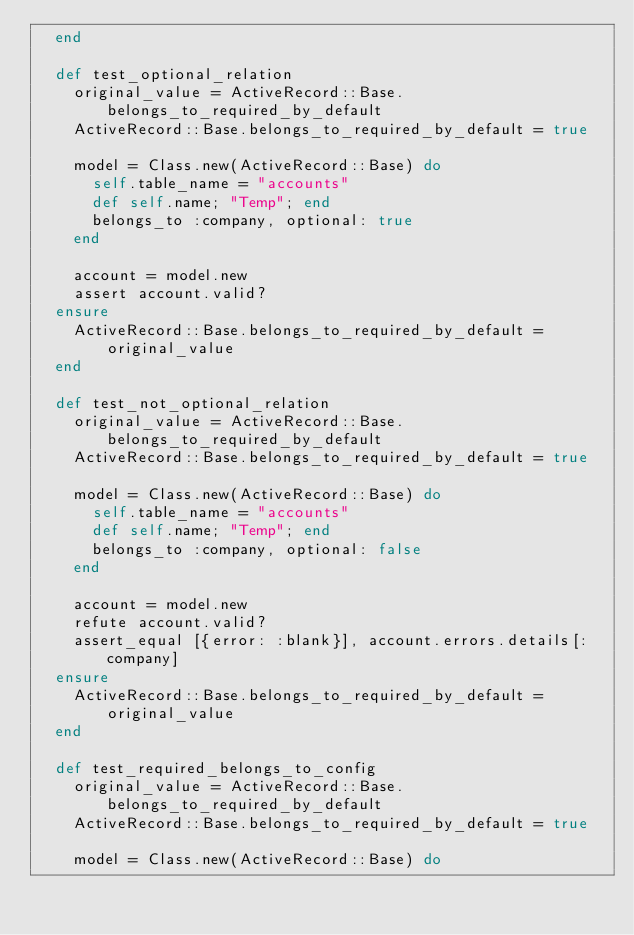Convert code to text. <code><loc_0><loc_0><loc_500><loc_500><_Ruby_>  end

  def test_optional_relation
    original_value = ActiveRecord::Base.belongs_to_required_by_default
    ActiveRecord::Base.belongs_to_required_by_default = true

    model = Class.new(ActiveRecord::Base) do
      self.table_name = "accounts"
      def self.name; "Temp"; end
      belongs_to :company, optional: true
    end

    account = model.new
    assert account.valid?
  ensure
    ActiveRecord::Base.belongs_to_required_by_default = original_value
  end

  def test_not_optional_relation
    original_value = ActiveRecord::Base.belongs_to_required_by_default
    ActiveRecord::Base.belongs_to_required_by_default = true

    model = Class.new(ActiveRecord::Base) do
      self.table_name = "accounts"
      def self.name; "Temp"; end
      belongs_to :company, optional: false
    end

    account = model.new
    refute account.valid?
    assert_equal [{error: :blank}], account.errors.details[:company]
  ensure
    ActiveRecord::Base.belongs_to_required_by_default = original_value
  end

  def test_required_belongs_to_config
    original_value = ActiveRecord::Base.belongs_to_required_by_default
    ActiveRecord::Base.belongs_to_required_by_default = true

    model = Class.new(ActiveRecord::Base) do</code> 